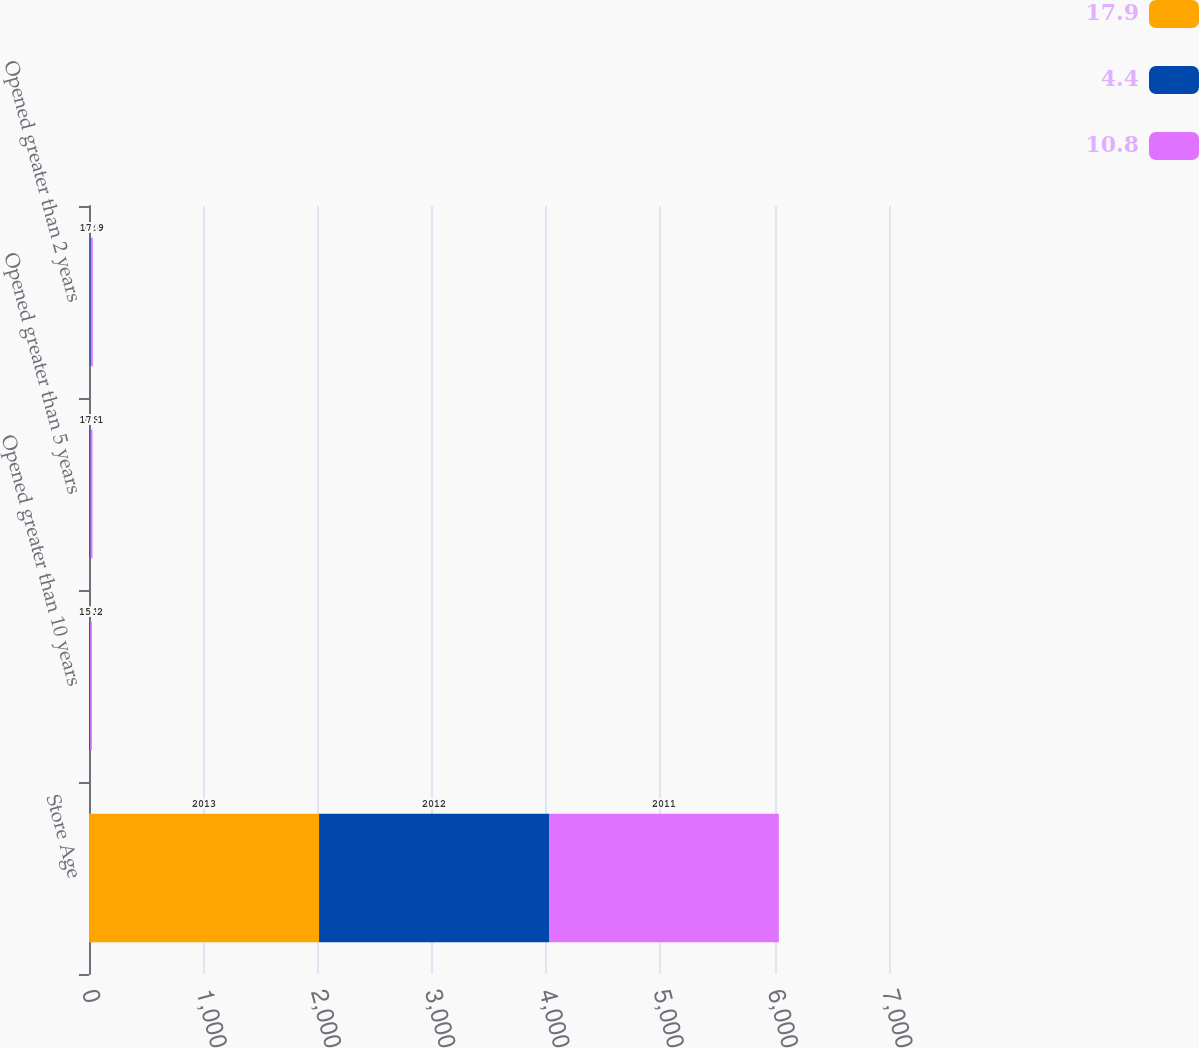Convert chart. <chart><loc_0><loc_0><loc_500><loc_500><stacked_bar_chart><ecel><fcel>Store Age<fcel>Opened greater than 10 years<fcel>Opened greater than 5 years<fcel>Opened greater than 2 years<nl><fcel>17.9<fcel>2013<fcel>2.1<fcel>3.6<fcel>4.4<nl><fcel>4.4<fcel>2012<fcel>8.1<fcel>9.8<fcel>10.8<nl><fcel>10.8<fcel>2011<fcel>15.2<fcel>17.1<fcel>17.9<nl></chart> 